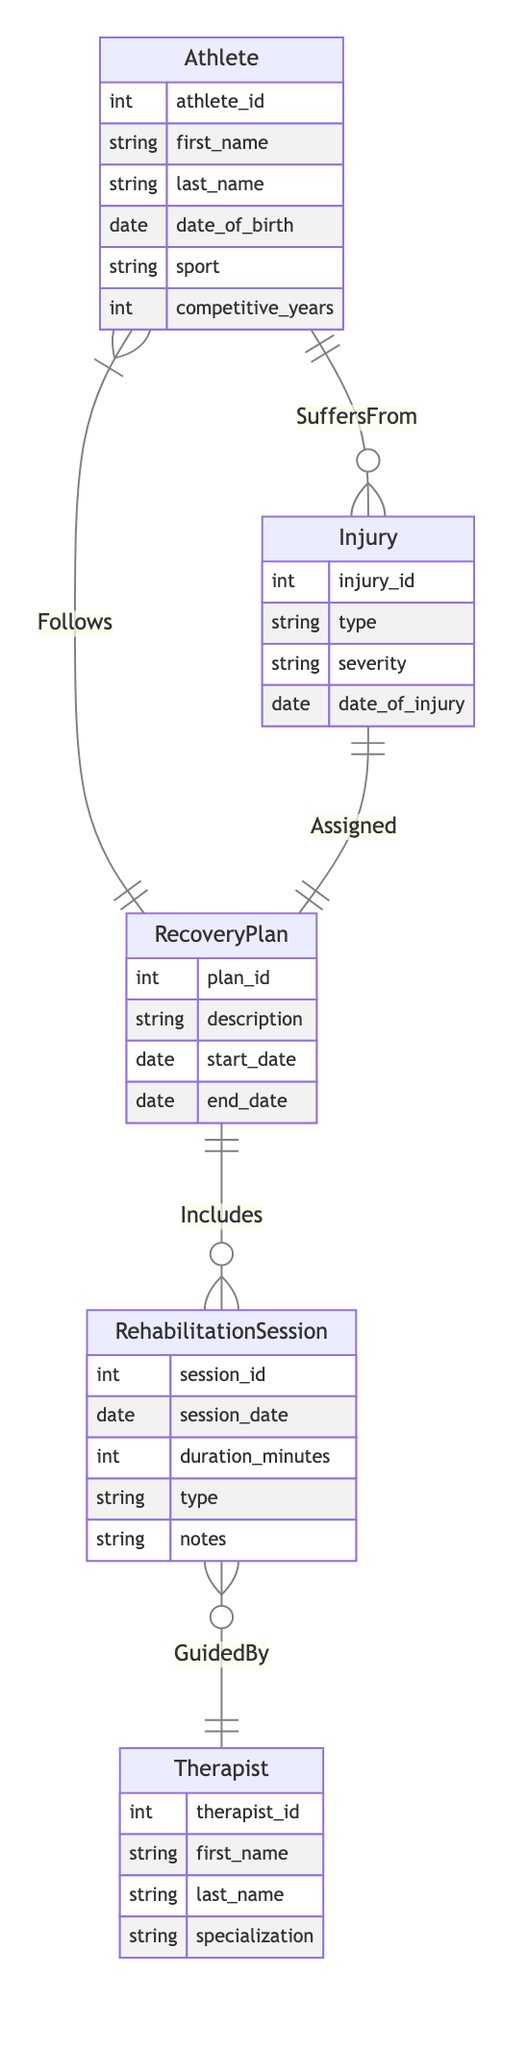What is the relationship between Athlete and Injury? The diagram shows that the relationship between Athlete and Injury is labeled as "SuffersFrom," indicating that an athlete can suffer from multiple injuries.
Answer: SuffersFrom How many attributes does the Injury entity have? The Injury entity has four attributes listed in the diagram: injury_id, type, severity, and date_of_injury. Counting these gives a total of four.
Answer: Four What is the type of the relationship between RecoveryPlan and RehabilitationSession? In the diagram, the relationship between RecoveryPlan and RehabilitationSession is labeled as "Includes," which is classified as a one-to-many relationship.
Answer: One-to-many How many sessions can a single RecoveryPlan include? The "Includes" relationship indicates that one RecoveryPlan can have multiple RehabilitationSessions associated with it; thus, a single RecoveryPlan can include many sessions.
Answer: Many What specialization must a Therapist have? The role of a Therapist includes a specialization, which is an attribute that describes the field of expertise or focus required to guide rehabilitation sessions.
Answer: Specialization What entity is guided by a Therapist during rehabilitation? The RehabilitationSession is the entity that is guided by a Therapist as observed in the "GuidedBy" relationship within the diagram.
Answer: RehabilitationSession How many times can an athlete follow different RecoveryPlans? The relationship between Athlete and RecoveryPlan is labeled as "Follows," indicating that an athlete can follow multiple RecoveryPlans throughout their athletic career.
Answer: Many Which entity has a one-to-one relationship with Injury? The diagram indicates that Injury has a one-to-one relationship with RecoveryPlan, labeled as "Assigned." This means each injury corresponds to exactly one recovery plan.
Answer: RecoveryPlan What does the attribute "duration_minutes" refer to? The attribute "duration_minutes" refers to the length of time for each RehabilitationSession, indicating how long the session lasts.
Answer: Length of session 